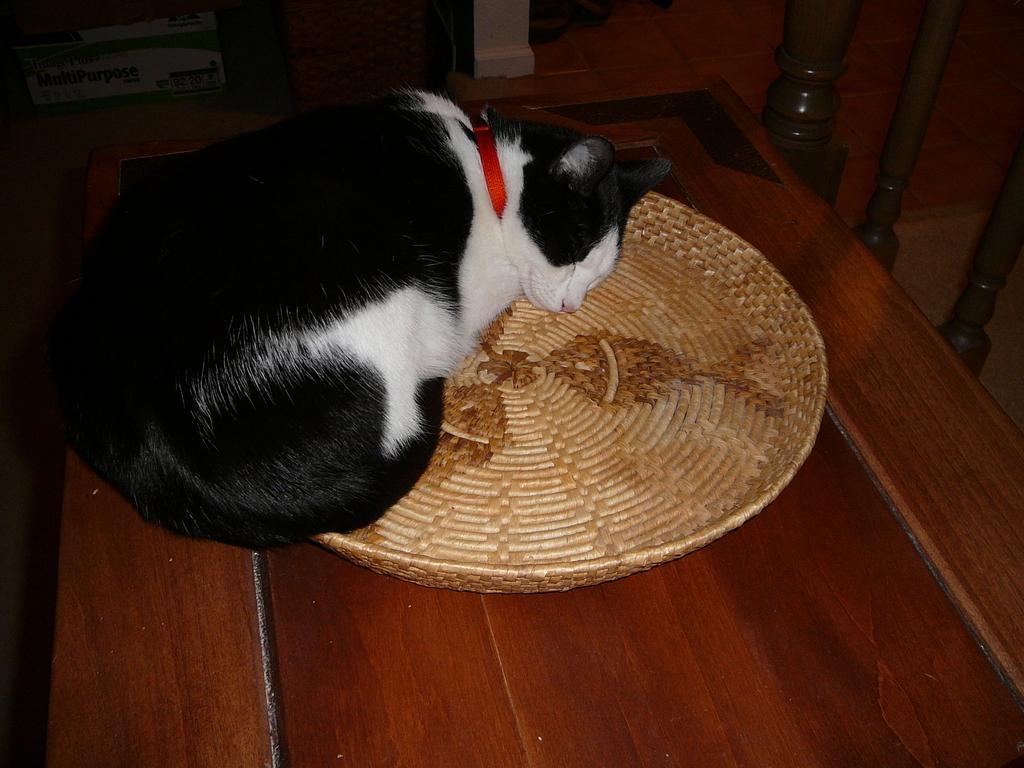Please provide a concise description of this image. A cat is sleeping on the basket, it is in black and white color. 